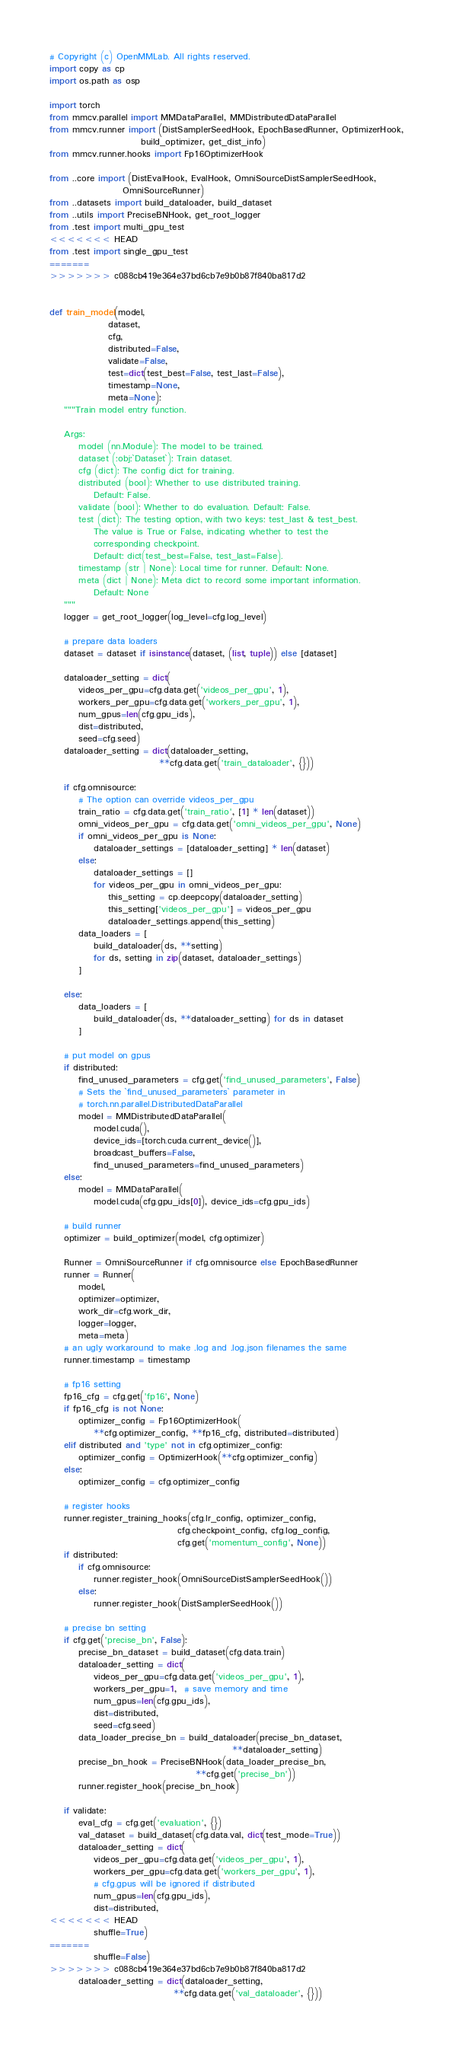Convert code to text. <code><loc_0><loc_0><loc_500><loc_500><_Python_># Copyright (c) OpenMMLab. All rights reserved.
import copy as cp
import os.path as osp

import torch
from mmcv.parallel import MMDataParallel, MMDistributedDataParallel
from mmcv.runner import (DistSamplerSeedHook, EpochBasedRunner, OptimizerHook,
                         build_optimizer, get_dist_info)
from mmcv.runner.hooks import Fp16OptimizerHook

from ..core import (DistEvalHook, EvalHook, OmniSourceDistSamplerSeedHook,
                    OmniSourceRunner)
from ..datasets import build_dataloader, build_dataset
from ..utils import PreciseBNHook, get_root_logger
from .test import multi_gpu_test
<<<<<<< HEAD
from .test import single_gpu_test
=======
>>>>>>> c088cb419e364e37bd6cb7e9b0b87f840ba817d2


def train_model(model,
                dataset,
                cfg,
                distributed=False,
                validate=False,
                test=dict(test_best=False, test_last=False),
                timestamp=None,
                meta=None):
    """Train model entry function.

    Args:
        model (nn.Module): The model to be trained.
        dataset (:obj:`Dataset`): Train dataset.
        cfg (dict): The config dict for training.
        distributed (bool): Whether to use distributed training.
            Default: False.
        validate (bool): Whether to do evaluation. Default: False.
        test (dict): The testing option, with two keys: test_last & test_best.
            The value is True or False, indicating whether to test the
            corresponding checkpoint.
            Default: dict(test_best=False, test_last=False).
        timestamp (str | None): Local time for runner. Default: None.
        meta (dict | None): Meta dict to record some important information.
            Default: None
    """
    logger = get_root_logger(log_level=cfg.log_level)

    # prepare data loaders
    dataset = dataset if isinstance(dataset, (list, tuple)) else [dataset]

    dataloader_setting = dict(
        videos_per_gpu=cfg.data.get('videos_per_gpu', 1),
        workers_per_gpu=cfg.data.get('workers_per_gpu', 1),
        num_gpus=len(cfg.gpu_ids),
        dist=distributed,
        seed=cfg.seed)
    dataloader_setting = dict(dataloader_setting,
                              **cfg.data.get('train_dataloader', {}))

    if cfg.omnisource:
        # The option can override videos_per_gpu
        train_ratio = cfg.data.get('train_ratio', [1] * len(dataset))
        omni_videos_per_gpu = cfg.data.get('omni_videos_per_gpu', None)
        if omni_videos_per_gpu is None:
            dataloader_settings = [dataloader_setting] * len(dataset)
        else:
            dataloader_settings = []
            for videos_per_gpu in omni_videos_per_gpu:
                this_setting = cp.deepcopy(dataloader_setting)
                this_setting['videos_per_gpu'] = videos_per_gpu
                dataloader_settings.append(this_setting)
        data_loaders = [
            build_dataloader(ds, **setting)
            for ds, setting in zip(dataset, dataloader_settings)
        ]

    else:
        data_loaders = [
            build_dataloader(ds, **dataloader_setting) for ds in dataset
        ]

    # put model on gpus
    if distributed:
        find_unused_parameters = cfg.get('find_unused_parameters', False)
        # Sets the `find_unused_parameters` parameter in
        # torch.nn.parallel.DistributedDataParallel
        model = MMDistributedDataParallel(
            model.cuda(),
            device_ids=[torch.cuda.current_device()],
            broadcast_buffers=False,
            find_unused_parameters=find_unused_parameters)
    else:
        model = MMDataParallel(
            model.cuda(cfg.gpu_ids[0]), device_ids=cfg.gpu_ids)

    # build runner
    optimizer = build_optimizer(model, cfg.optimizer)

    Runner = OmniSourceRunner if cfg.omnisource else EpochBasedRunner
    runner = Runner(
        model,
        optimizer=optimizer,
        work_dir=cfg.work_dir,
        logger=logger,
        meta=meta)
    # an ugly workaround to make .log and .log.json filenames the same
    runner.timestamp = timestamp

    # fp16 setting
    fp16_cfg = cfg.get('fp16', None)
    if fp16_cfg is not None:
        optimizer_config = Fp16OptimizerHook(
            **cfg.optimizer_config, **fp16_cfg, distributed=distributed)
    elif distributed and 'type' not in cfg.optimizer_config:
        optimizer_config = OptimizerHook(**cfg.optimizer_config)
    else:
        optimizer_config = cfg.optimizer_config

    # register hooks
    runner.register_training_hooks(cfg.lr_config, optimizer_config,
                                   cfg.checkpoint_config, cfg.log_config,
                                   cfg.get('momentum_config', None))
    if distributed:
        if cfg.omnisource:
            runner.register_hook(OmniSourceDistSamplerSeedHook())
        else:
            runner.register_hook(DistSamplerSeedHook())

    # precise bn setting
    if cfg.get('precise_bn', False):
        precise_bn_dataset = build_dataset(cfg.data.train)
        dataloader_setting = dict(
            videos_per_gpu=cfg.data.get('videos_per_gpu', 1),
            workers_per_gpu=1,  # save memory and time
            num_gpus=len(cfg.gpu_ids),
            dist=distributed,
            seed=cfg.seed)
        data_loader_precise_bn = build_dataloader(precise_bn_dataset,
                                                  **dataloader_setting)
        precise_bn_hook = PreciseBNHook(data_loader_precise_bn,
                                        **cfg.get('precise_bn'))
        runner.register_hook(precise_bn_hook)

    if validate:
        eval_cfg = cfg.get('evaluation', {})
        val_dataset = build_dataset(cfg.data.val, dict(test_mode=True))
        dataloader_setting = dict(
            videos_per_gpu=cfg.data.get('videos_per_gpu', 1),
            workers_per_gpu=cfg.data.get('workers_per_gpu', 1),
            # cfg.gpus will be ignored if distributed
            num_gpus=len(cfg.gpu_ids),
            dist=distributed,
<<<<<<< HEAD
            shuffle=True)
=======
            shuffle=False)
>>>>>>> c088cb419e364e37bd6cb7e9b0b87f840ba817d2
        dataloader_setting = dict(dataloader_setting,
                                  **cfg.data.get('val_dataloader', {}))</code> 